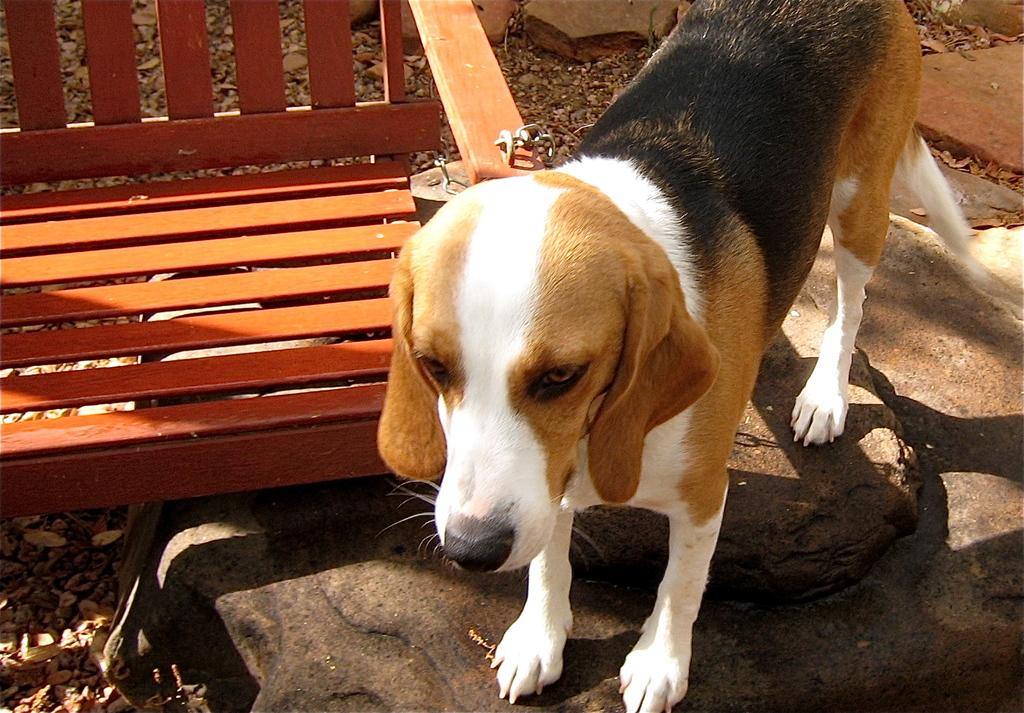What animal can be seen in the image? There is a dog in the image. Where is the dog located in relation to other objects? The dog is standing near a wooden table. What type of surface can be seen on the right side of the image? There are stones visible on the right side of the image. What type of plant material is present in the bottom left corner of the image? Leaves are present in the bottom left corner of the image. What type of trade is being conducted in the image? There is no indication of any trade being conducted in the image; it features a dog standing near a wooden table with stones and leaves visible. Can you see a knife in the image? No, there is no knife present in the image. 